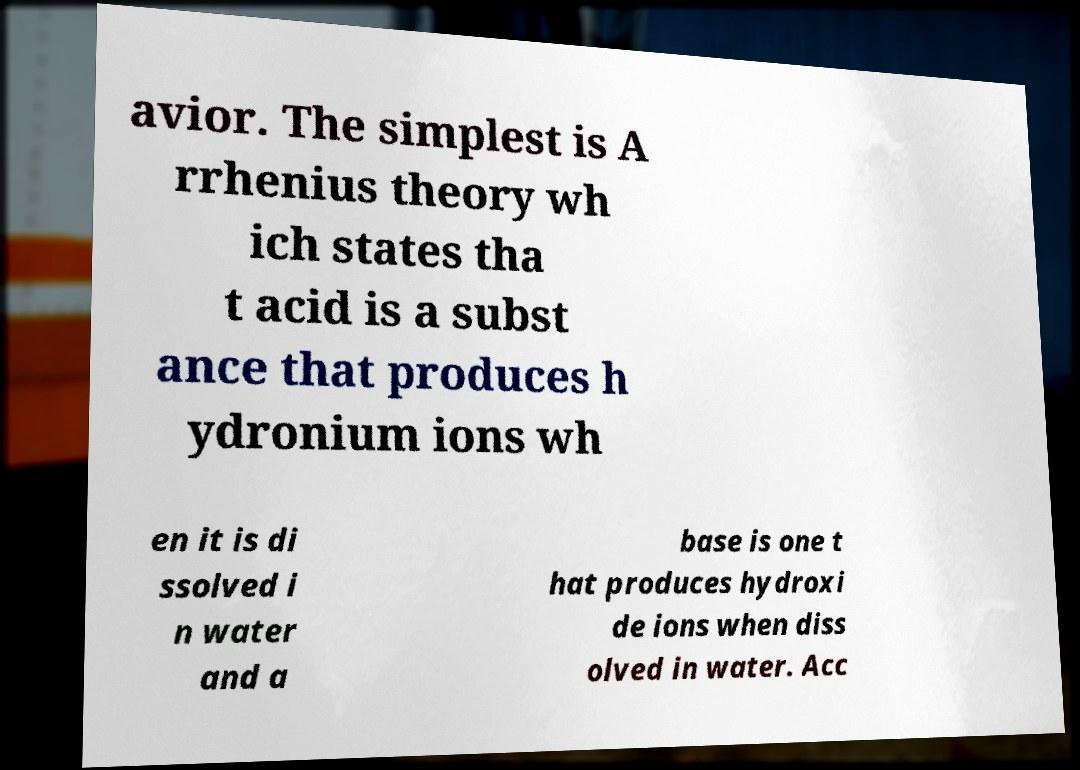Could you assist in decoding the text presented in this image and type it out clearly? avior. The simplest is A rrhenius theory wh ich states tha t acid is a subst ance that produces h ydronium ions wh en it is di ssolved i n water and a base is one t hat produces hydroxi de ions when diss olved in water. Acc 